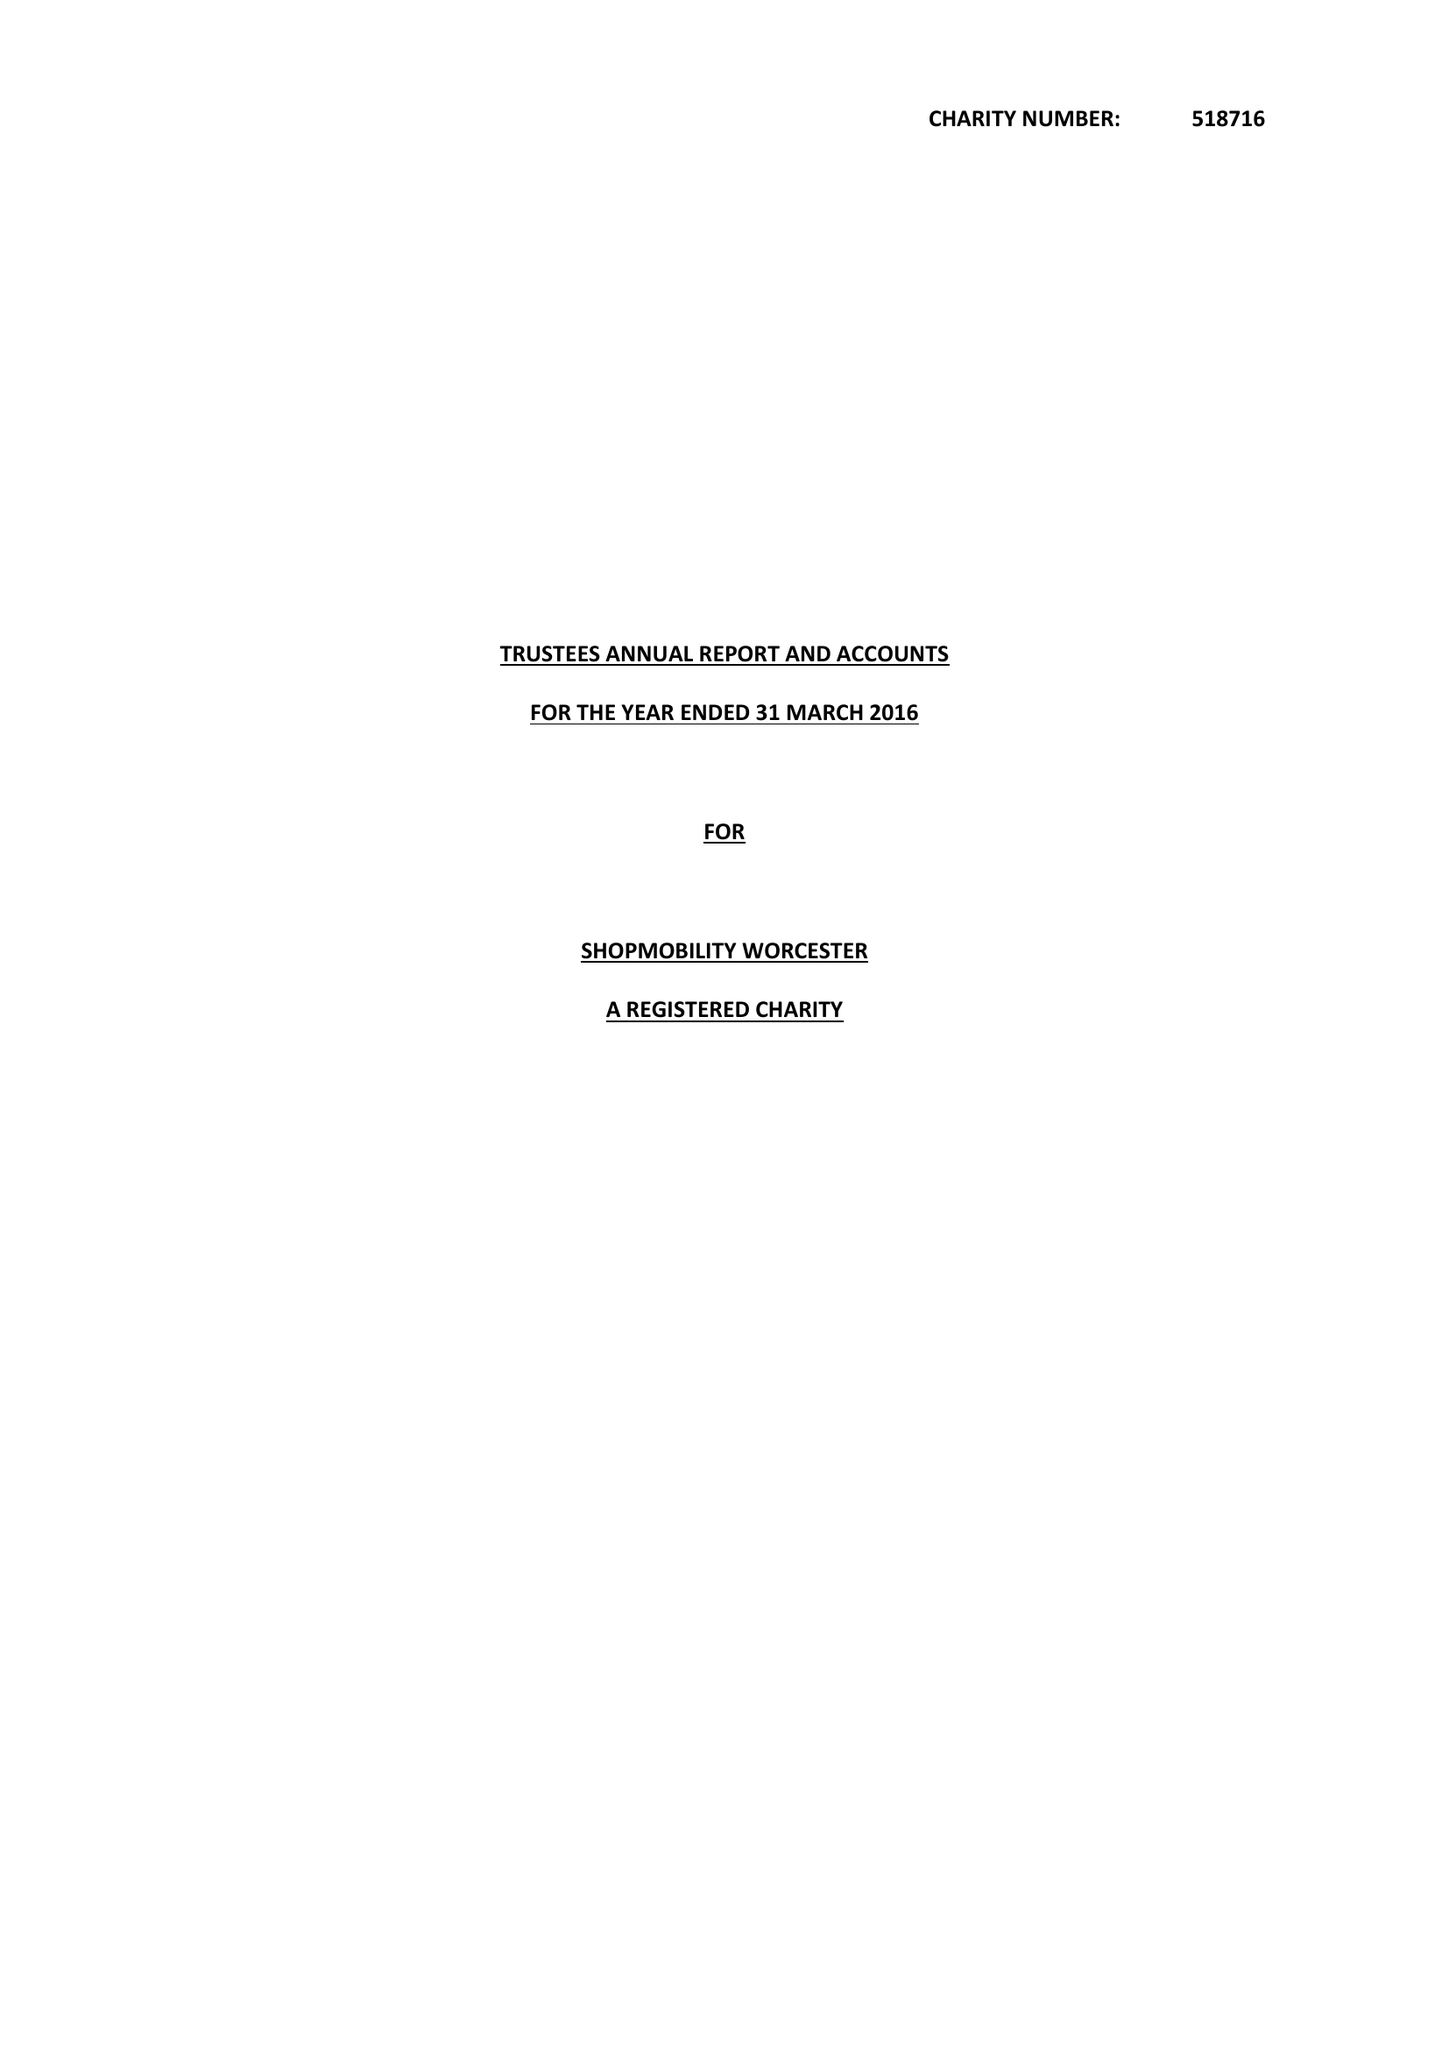What is the value for the income_annually_in_british_pounds?
Answer the question using a single word or phrase. 27055.00 